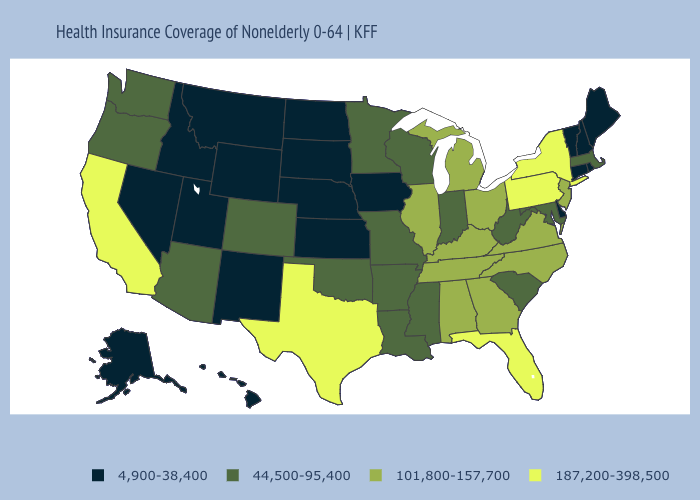Name the states that have a value in the range 187,200-398,500?
Be succinct. California, Florida, New York, Pennsylvania, Texas. What is the lowest value in the USA?
Give a very brief answer. 4,900-38,400. What is the value of Maryland?
Short answer required. 44,500-95,400. What is the value of New Jersey?
Keep it brief. 101,800-157,700. What is the highest value in the USA?
Concise answer only. 187,200-398,500. Which states have the highest value in the USA?
Short answer required. California, Florida, New York, Pennsylvania, Texas. Name the states that have a value in the range 4,900-38,400?
Give a very brief answer. Alaska, Connecticut, Delaware, Hawaii, Idaho, Iowa, Kansas, Maine, Montana, Nebraska, Nevada, New Hampshire, New Mexico, North Dakota, Rhode Island, South Dakota, Utah, Vermont, Wyoming. Among the states that border Wyoming , which have the highest value?
Short answer required. Colorado. Which states hav the highest value in the West?
Answer briefly. California. Does Oregon have the lowest value in the West?
Be succinct. No. Name the states that have a value in the range 101,800-157,700?
Give a very brief answer. Alabama, Georgia, Illinois, Kentucky, Michigan, New Jersey, North Carolina, Ohio, Tennessee, Virginia. Which states have the lowest value in the West?
Give a very brief answer. Alaska, Hawaii, Idaho, Montana, Nevada, New Mexico, Utah, Wyoming. Does Oregon have the highest value in the West?
Quick response, please. No. Name the states that have a value in the range 4,900-38,400?
Give a very brief answer. Alaska, Connecticut, Delaware, Hawaii, Idaho, Iowa, Kansas, Maine, Montana, Nebraska, Nevada, New Hampshire, New Mexico, North Dakota, Rhode Island, South Dakota, Utah, Vermont, Wyoming. 